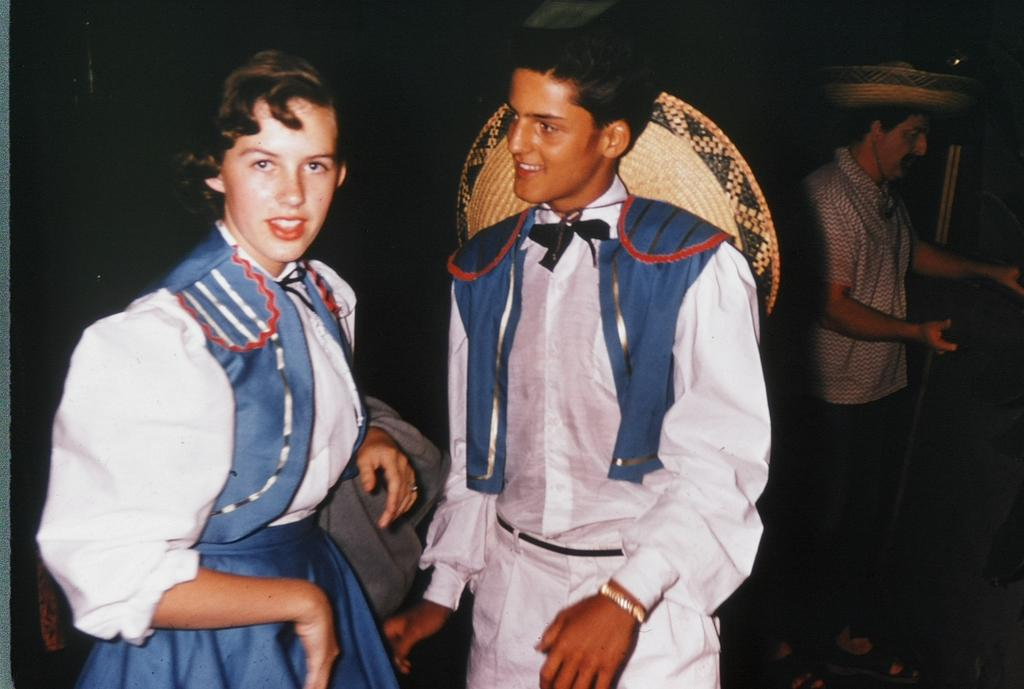How many people are present in the image? There are three people in the image. What are the people wearing on their heads? Some of the people are wearing hats. Can you describe any objects in the image? There are objects in the image, but their specific details are not mentioned in the facts. What is the expression on the faces of two of the people? Two of the people are smiling. How would you describe the lighting in the image? The background of the image is dark. What type of flowers can be seen growing in the square in the image? There is no square or flowers present in the image. 